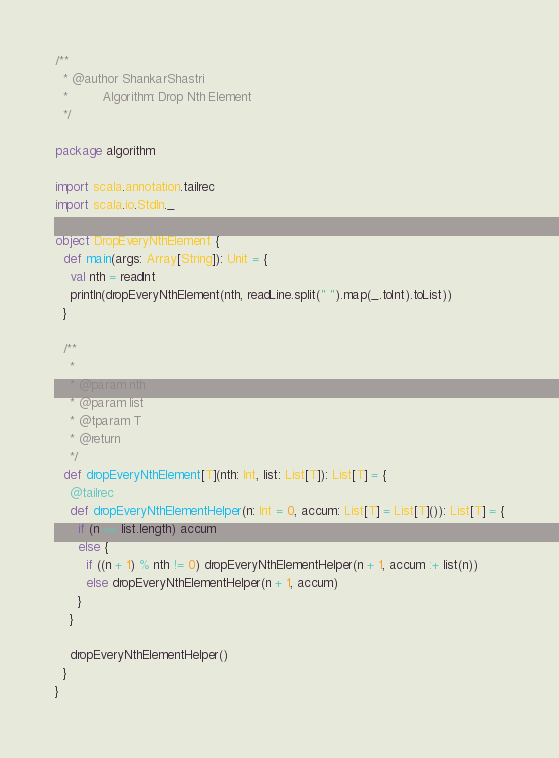<code> <loc_0><loc_0><loc_500><loc_500><_Scala_>/**
  * @author ShankarShastri
  *         Algorithm: Drop Nth Element
  */

package algorithm

import scala.annotation.tailrec
import scala.io.StdIn._

object DropEveryNthElement {
  def main(args: Array[String]): Unit = {
    val nth = readInt
    println(dropEveryNthElement(nth, readLine.split(" ").map(_.toInt).toList))
  }

  /**
    *
    * @param nth
    * @param list
    * @tparam T
    * @return
    */
  def dropEveryNthElement[T](nth: Int, list: List[T]): List[T] = {
    @tailrec
    def dropEveryNthElementHelper(n: Int = 0, accum: List[T] = List[T]()): List[T] = {
      if (n == list.length) accum
      else {
        if ((n + 1) % nth != 0) dropEveryNthElementHelper(n + 1, accum :+ list(n))
        else dropEveryNthElementHelper(n + 1, accum)
      }
    }

    dropEveryNthElementHelper()
  }
}
</code> 